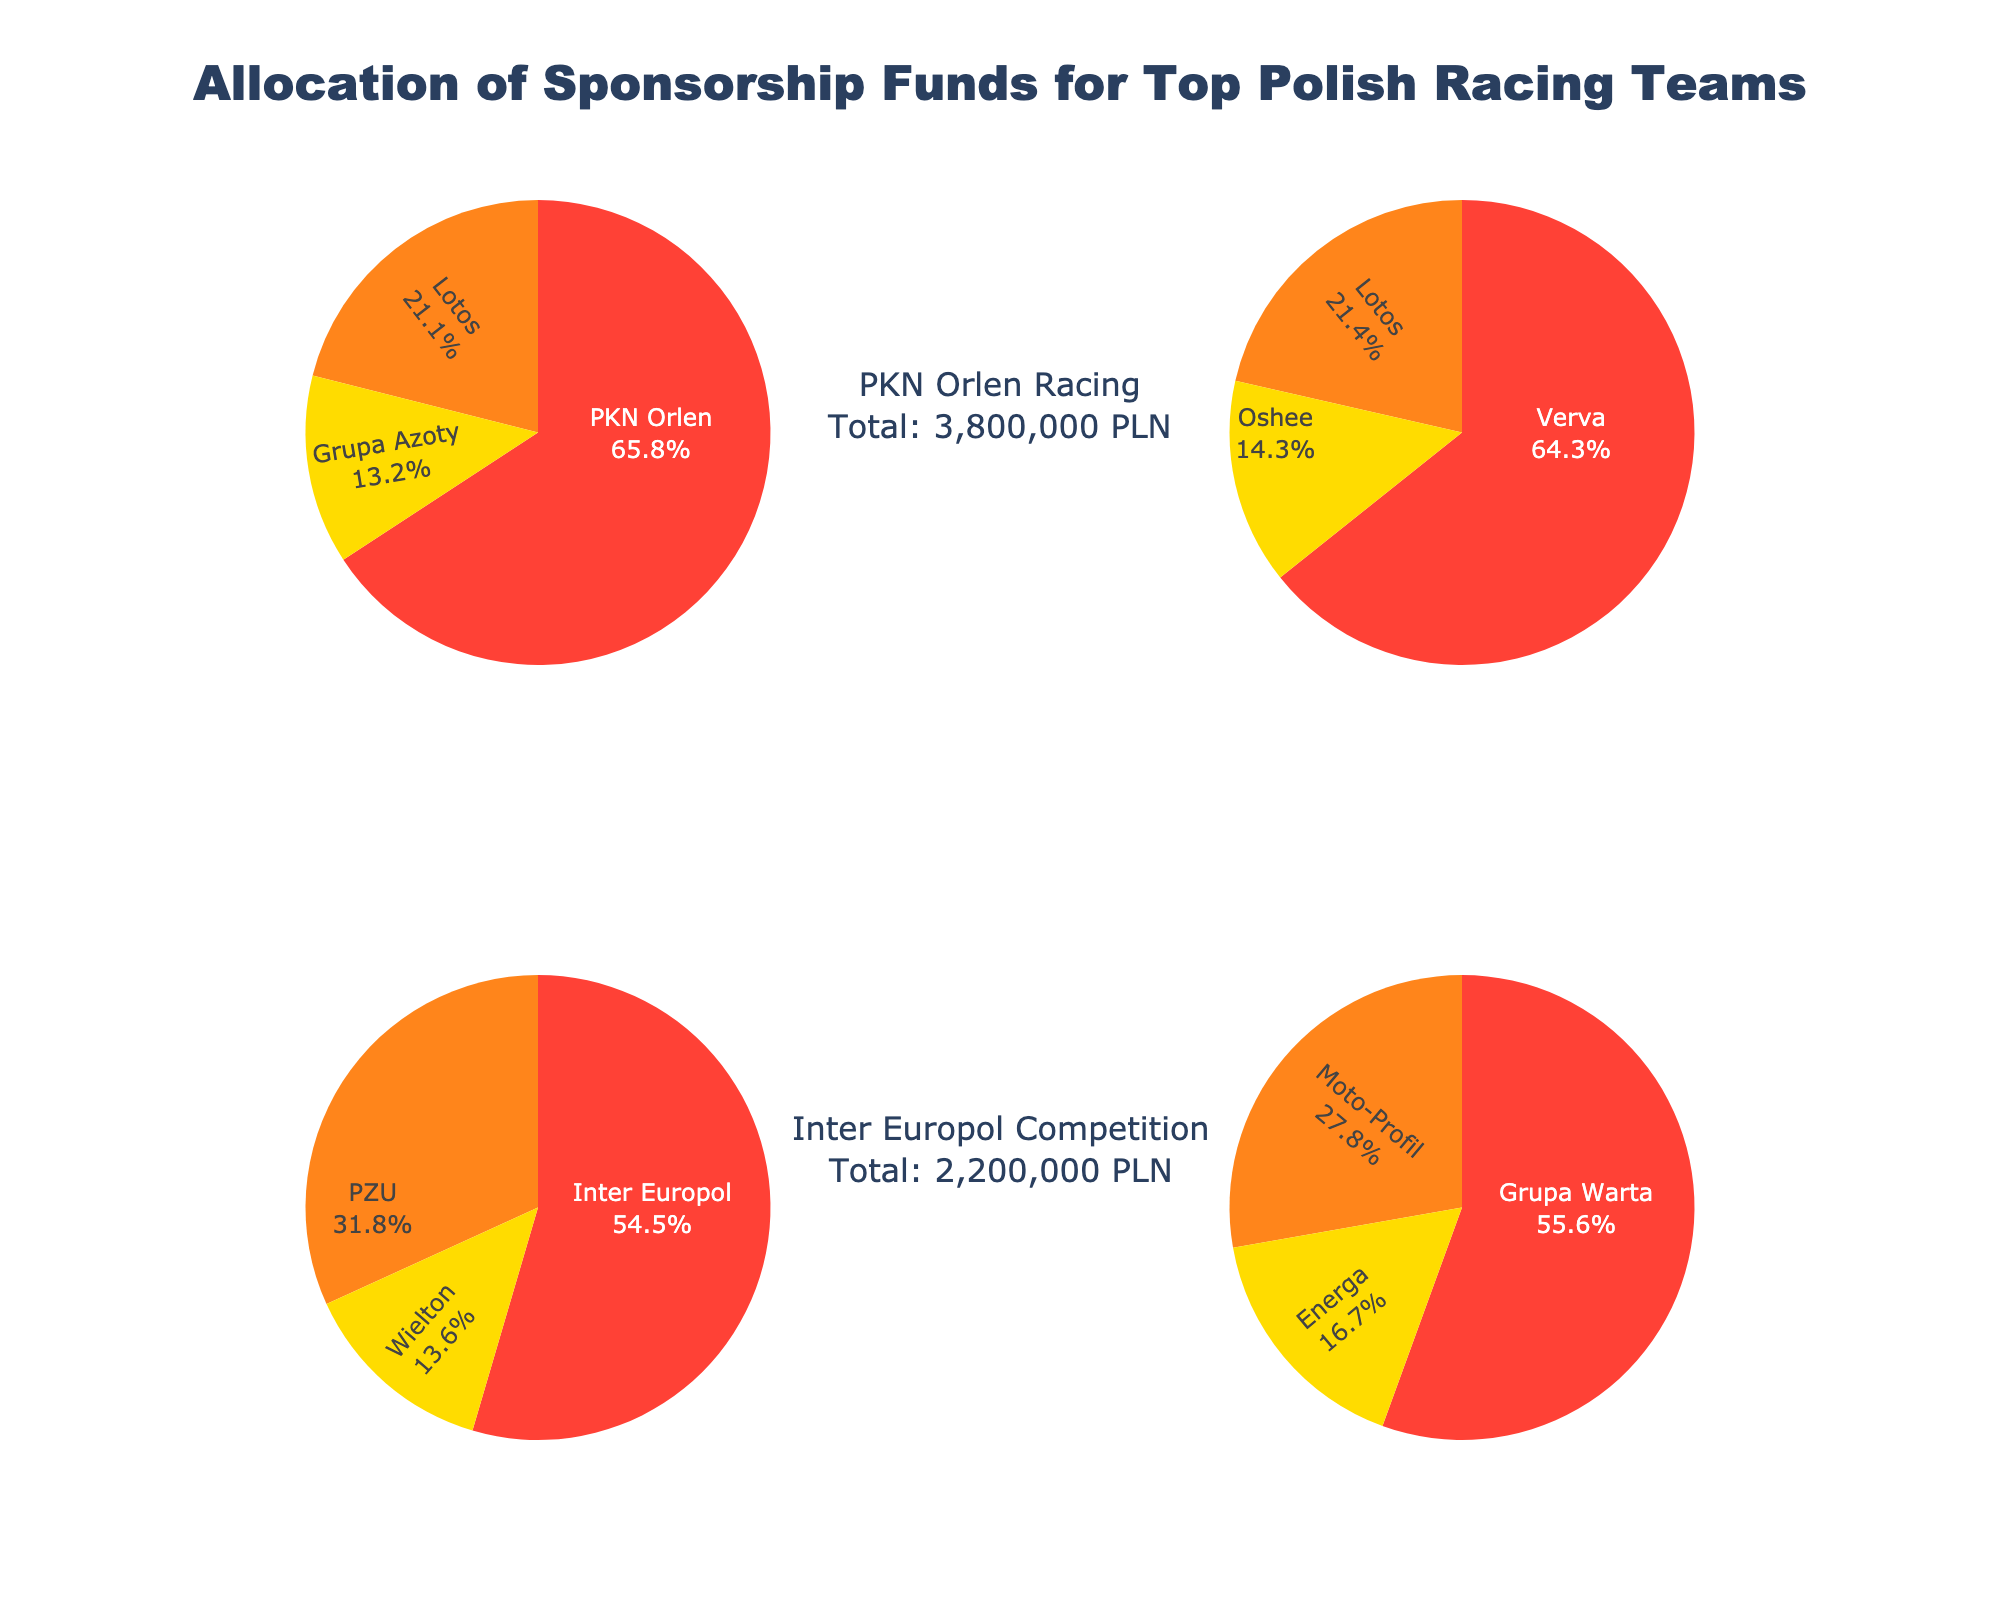what is the title of the figure? The title is written prominently at the top of the figure. It is "Allocation of Sponsorship Funds for Top Polish Racing Teams".
Answer: Allocation of Sponsorship Funds for Top Polish Racing Teams How many teams are represented in the figure? There are four subplots, each representing a different team. The subplot titles indicate the four teams.
Answer: 4 Which team has the largest single sponsorship contribution and from which sponsor? By observing the sizes of the pie chart slices, we can identify the largest. PKN Orlen Racing has the largest single contribution from PKN Orlen.
Answer: PKN Orlen Racing, PKN Orlen What percentage of Verva Racing Team's funding comes from their primary sponsor? Looking at the Verva Racing Team pie chart, the largest slice is from Verva. The chart shows the percentage directly.
Answer: 60% What is the total sponsorship amount for Inter Europol Competition? The annotations under each subplot list the total amount for each team. For Inter Europol Competition, it shows 2,200,000 PLN.
Answer: 2,200,000 PLN Which sponsor appears in multiple teams' sponsorship allocations? By examining the different sponsors in each pie chart, Lotos is a common sponsor for multiple teams, including PKN Orlen Racing and Verva Racing Team.
Answer: Lotos Compare the total sponsorship amounts for PKN Orlen Racing and RaceLab Motorsport. Which has more and by how much? The annotations indicate the total for PKN Orlen Racing is 3,300,000 PLN and for RaceLab Motorsport is 1,800,000 PLN. The difference is 3,300,000 - 1,800,000 = 1,500,000 PLN.
Answer: PKN Orlen Racing by 1,500,000 PLN What is the combined sponsorship amount from Lotos across all teams? Lotos sponsors PKN Orlen Racing (800,000 PLN) and Verva Racing Team (600,000 PLN). The total is 800,000 + 600,000 = 1,400,000 PLN.
Answer: 1,400,000 PLN What is the average sponsorship amount per sponsor for RaceLab Motorsport? RaceLab Motorsport has three sponsors contributing 1,800,000 PLN in total. The average is 1,800,000 / 3 = 600,000 PLN.
Answer: 600,000 PLN Which team has the most diversified sponsorship, i.e., the most evenly distributed among sponsors? By comparing the pie charts, RaceLab Motorsport has the most evenly distributed slices, indicating diversified sponsorship.
Answer: RaceLab Motorsport 